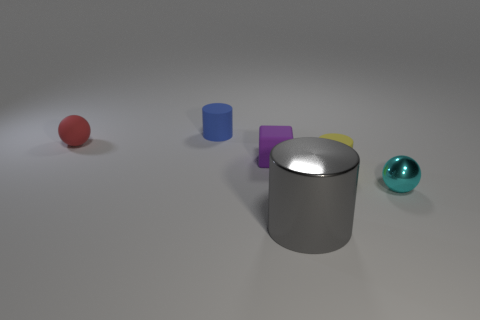Add 2 yellow matte cylinders. How many objects exist? 8 Subtract all balls. How many objects are left? 4 Add 2 small cyan balls. How many small cyan balls are left? 3 Add 5 cyan metal spheres. How many cyan metal spheres exist? 6 Subtract 0 cyan cylinders. How many objects are left? 6 Subtract all yellow objects. Subtract all yellow matte cylinders. How many objects are left? 4 